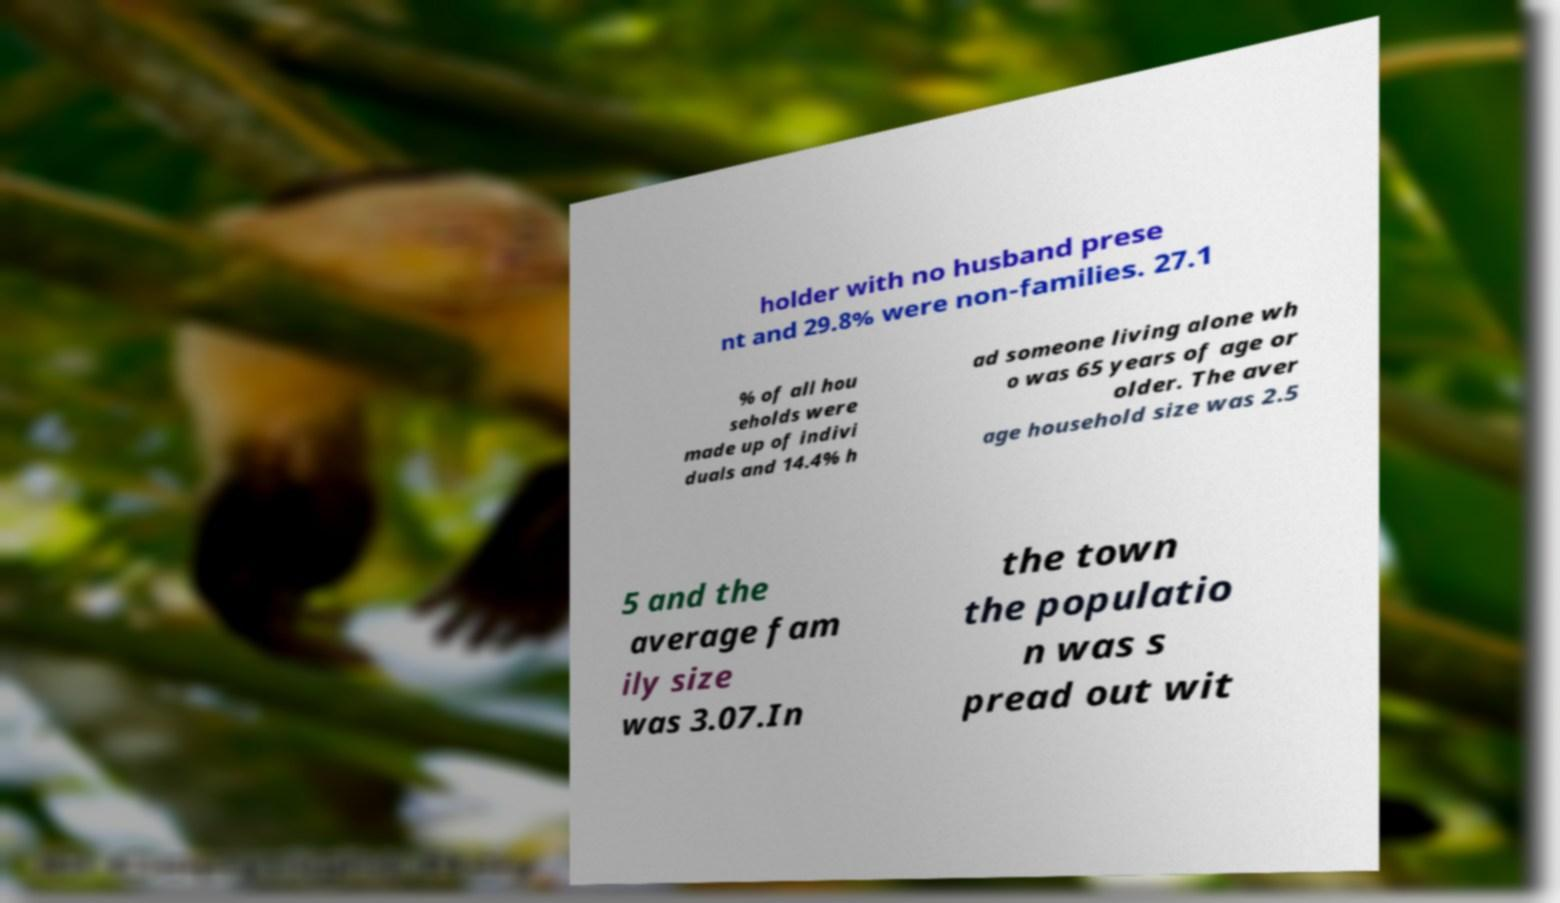Could you extract and type out the text from this image? holder with no husband prese nt and 29.8% were non-families. 27.1 % of all hou seholds were made up of indivi duals and 14.4% h ad someone living alone wh o was 65 years of age or older. The aver age household size was 2.5 5 and the average fam ily size was 3.07.In the town the populatio n was s pread out wit 